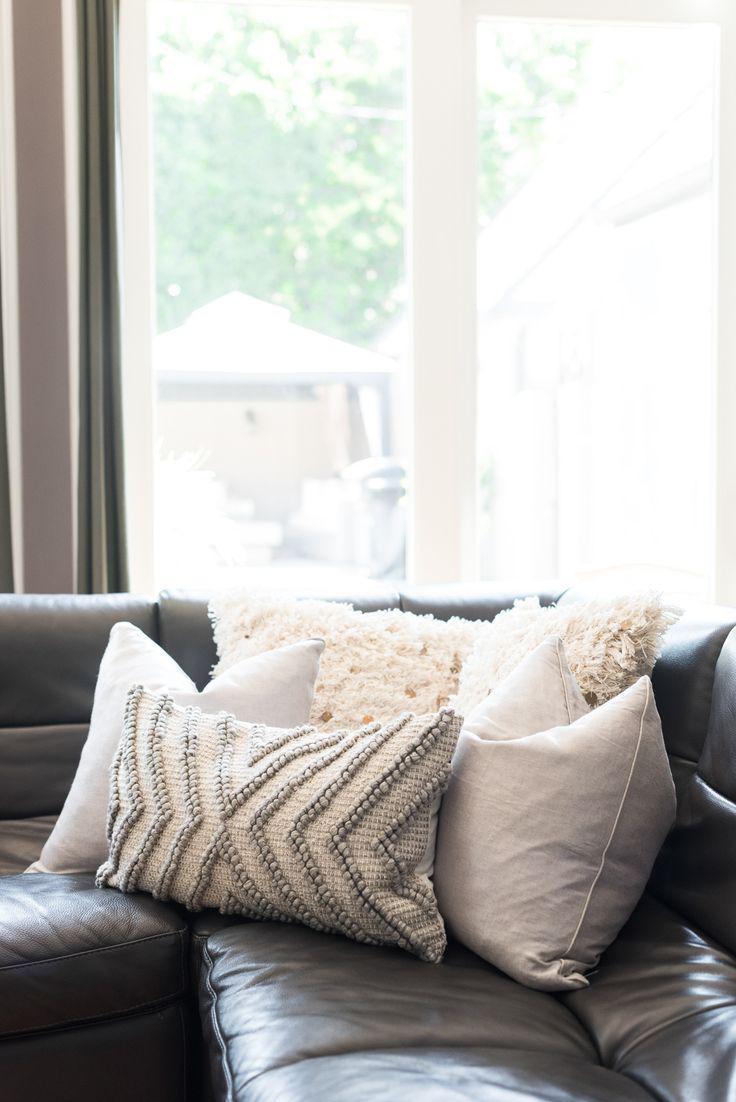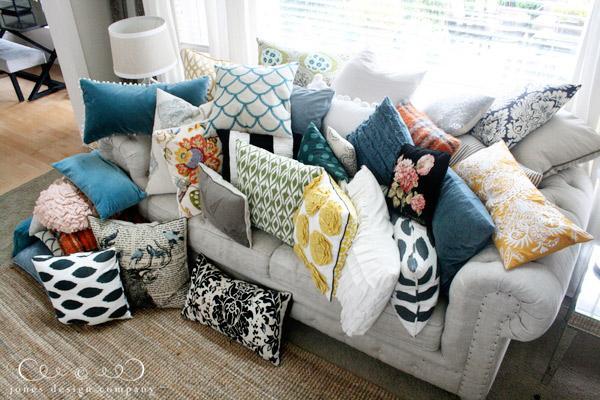The first image is the image on the left, the second image is the image on the right. For the images shown, is this caption "There is a plant on the coffee table in at least one image." true? Answer yes or no. No. The first image is the image on the left, the second image is the image on the right. Analyze the images presented: Is the assertion "In one image, a bottle and glass containing a drink are sitting near a seating area." valid? Answer yes or no. No. 